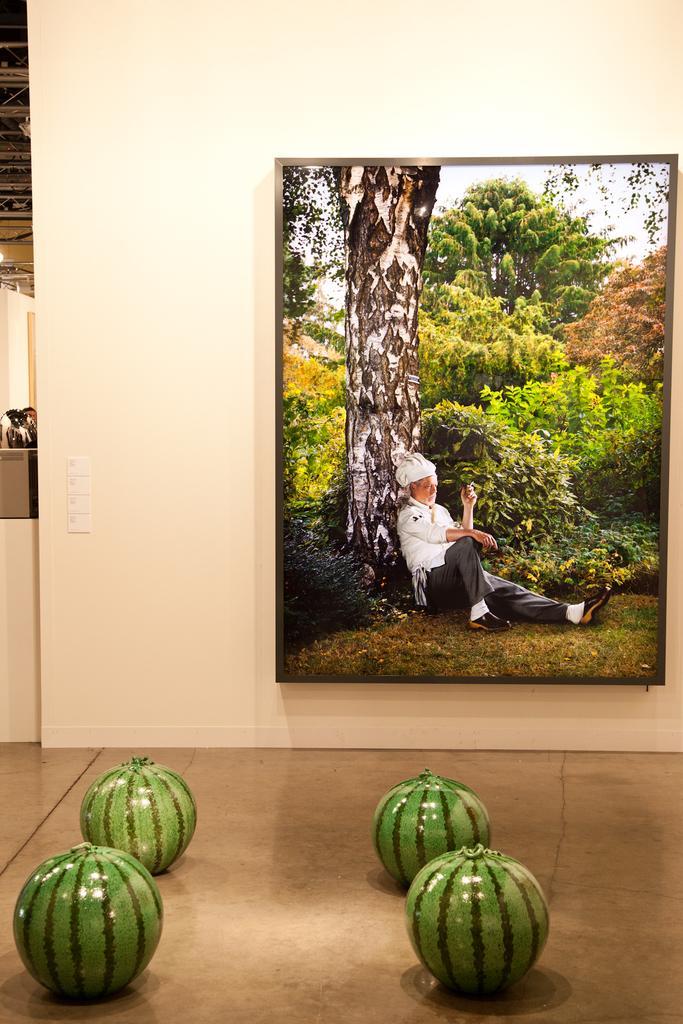Describe this image in one or two sentences. This picture is consists of a portrait, which is fixed on a wall, there are trees in the portrait and there is a man who is sitting in front of a tree, there are some watermelon type models which are kept in front of the portrait. 